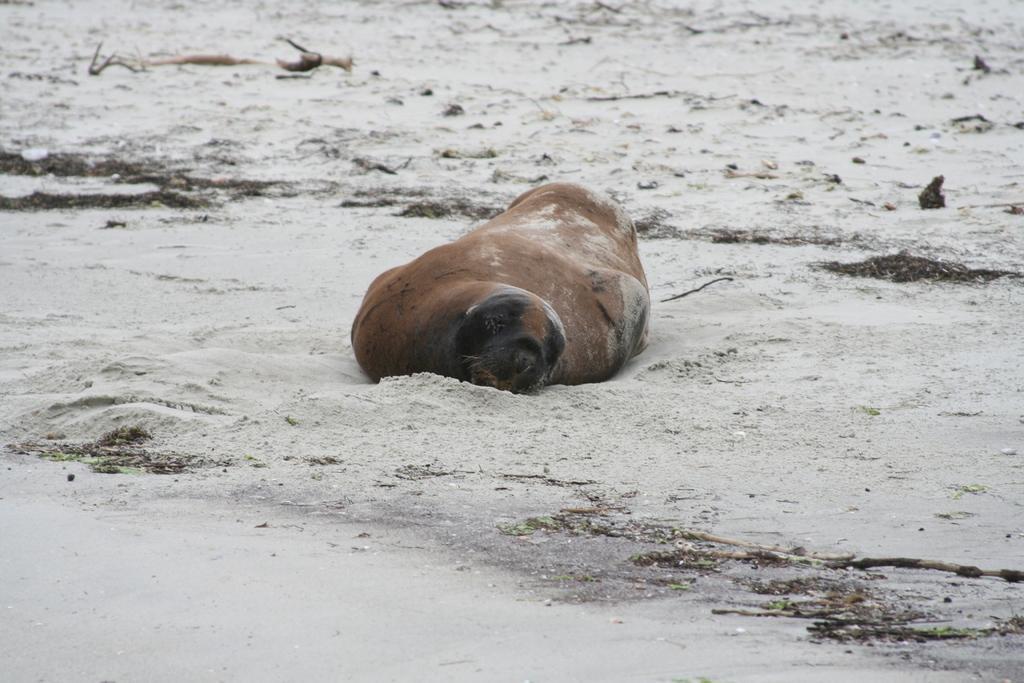Can you describe this image briefly? In this picture we can see a seal on the ground, sand and in the background we can see an object. 